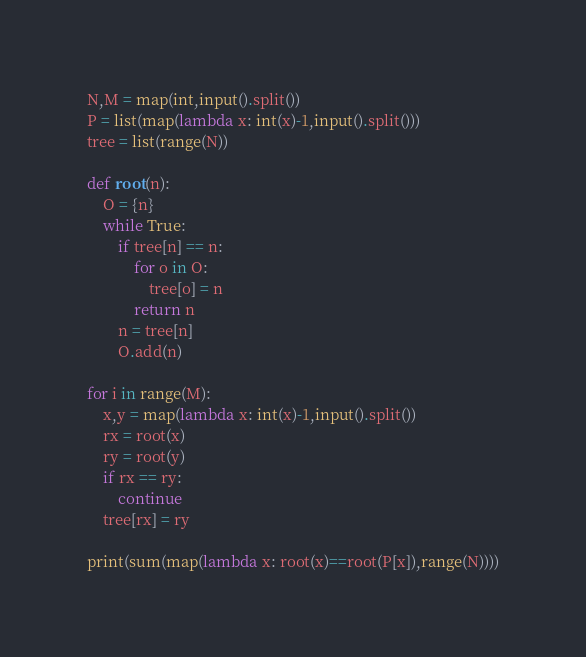Convert code to text. <code><loc_0><loc_0><loc_500><loc_500><_Python_>N,M = map(int,input().split())
P = list(map(lambda x: int(x)-1,input().split()))
tree = list(range(N))

def root(n):
    O = {n}
    while True:
        if tree[n] == n:
            for o in O:
                tree[o] = n
            return n
        n = tree[n]
        O.add(n)

for i in range(M):
    x,y = map(lambda x: int(x)-1,input().split())
    rx = root(x)
    ry = root(y)
    if rx == ry:
        continue
    tree[rx] = ry

print(sum(map(lambda x: root(x)==root(P[x]),range(N))))</code> 